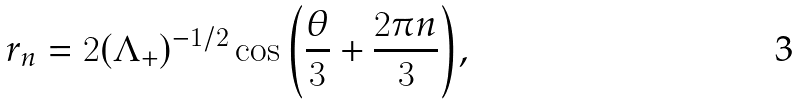<formula> <loc_0><loc_0><loc_500><loc_500>r _ { n } = 2 ( \Lambda _ { + } ) ^ { - 1 / 2 } \cos { \left ( \frac { \theta } { 3 } + \frac { 2 \pi n } { 3 } \right ) } ,</formula> 